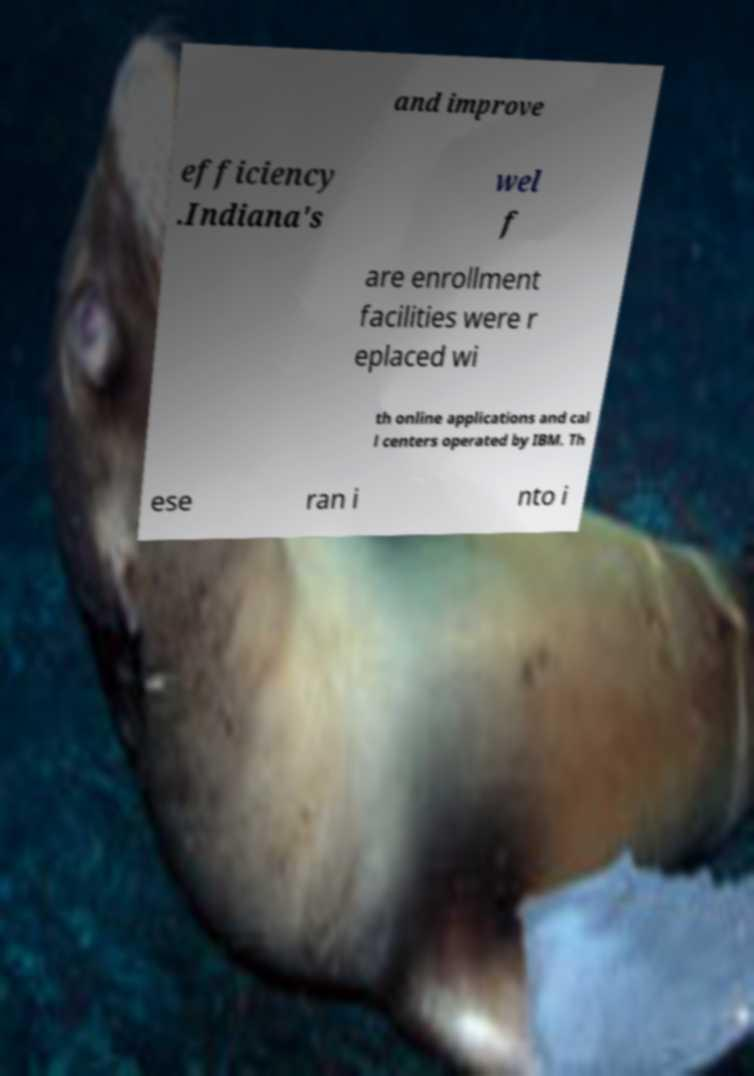There's text embedded in this image that I need extracted. Can you transcribe it verbatim? and improve efficiency .Indiana's wel f are enrollment facilities were r eplaced wi th online applications and cal l centers operated by IBM. Th ese ran i nto i 